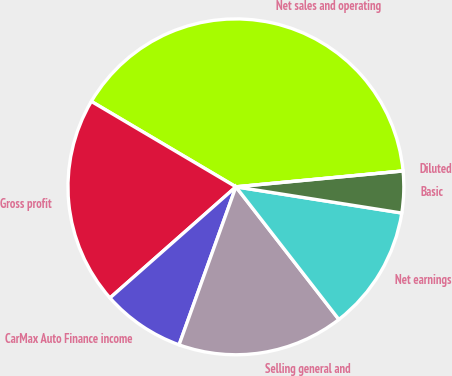Convert chart to OTSL. <chart><loc_0><loc_0><loc_500><loc_500><pie_chart><fcel>Net sales and operating<fcel>Gross profit<fcel>CarMax Auto Finance income<fcel>Selling general and<fcel>Net earnings<fcel>Basic<fcel>Diluted<nl><fcel>40.0%<fcel>20.0%<fcel>8.0%<fcel>16.0%<fcel>12.0%<fcel>4.0%<fcel>0.0%<nl></chart> 